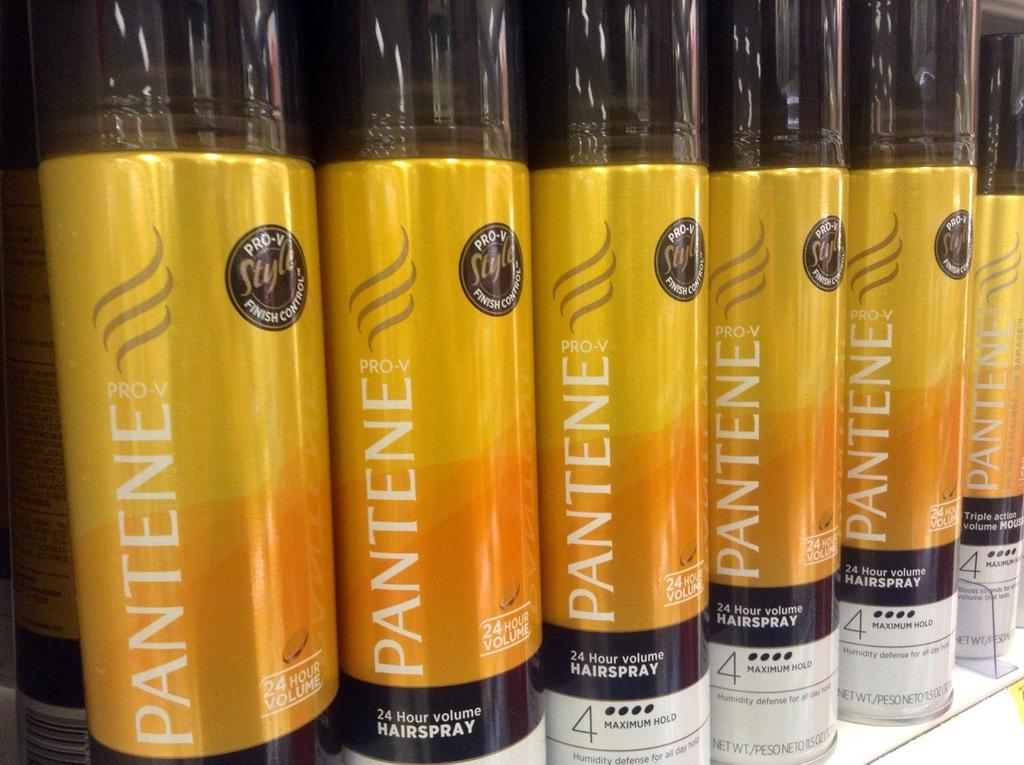<image>
Render a clear and concise summary of the photo. Several bottles of Pantene Pro-V hairspray are lined up. 